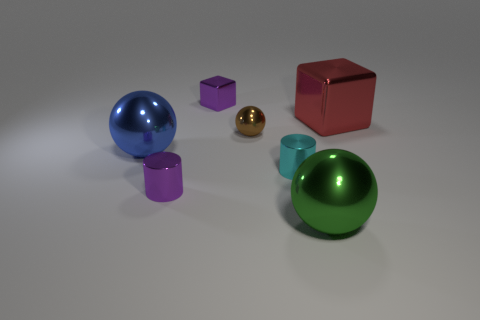There is another object that is the same shape as the red object; what is it made of?
Your answer should be very brief. Metal. The purple thing to the right of the tiny purple object in front of the small purple cube is what shape?
Offer a very short reply. Cube. What number of tiny objects are metal objects or yellow rubber blocks?
Provide a short and direct response. 4. What number of blue objects have the same shape as the big green shiny thing?
Your answer should be very brief. 1. Does the blue metal object have the same shape as the big shiny object that is in front of the blue thing?
Offer a very short reply. Yes. There is a blue metal ball; how many large metal balls are in front of it?
Offer a very short reply. 1. Are there any things of the same size as the blue sphere?
Your response must be concise. Yes. There is a purple object behind the small cyan metal object; is it the same shape as the red shiny object?
Your answer should be compact. Yes. What is the color of the big shiny cube?
Make the answer very short. Red. There is a object that is the same color as the small block; what is its shape?
Offer a terse response. Cylinder. 